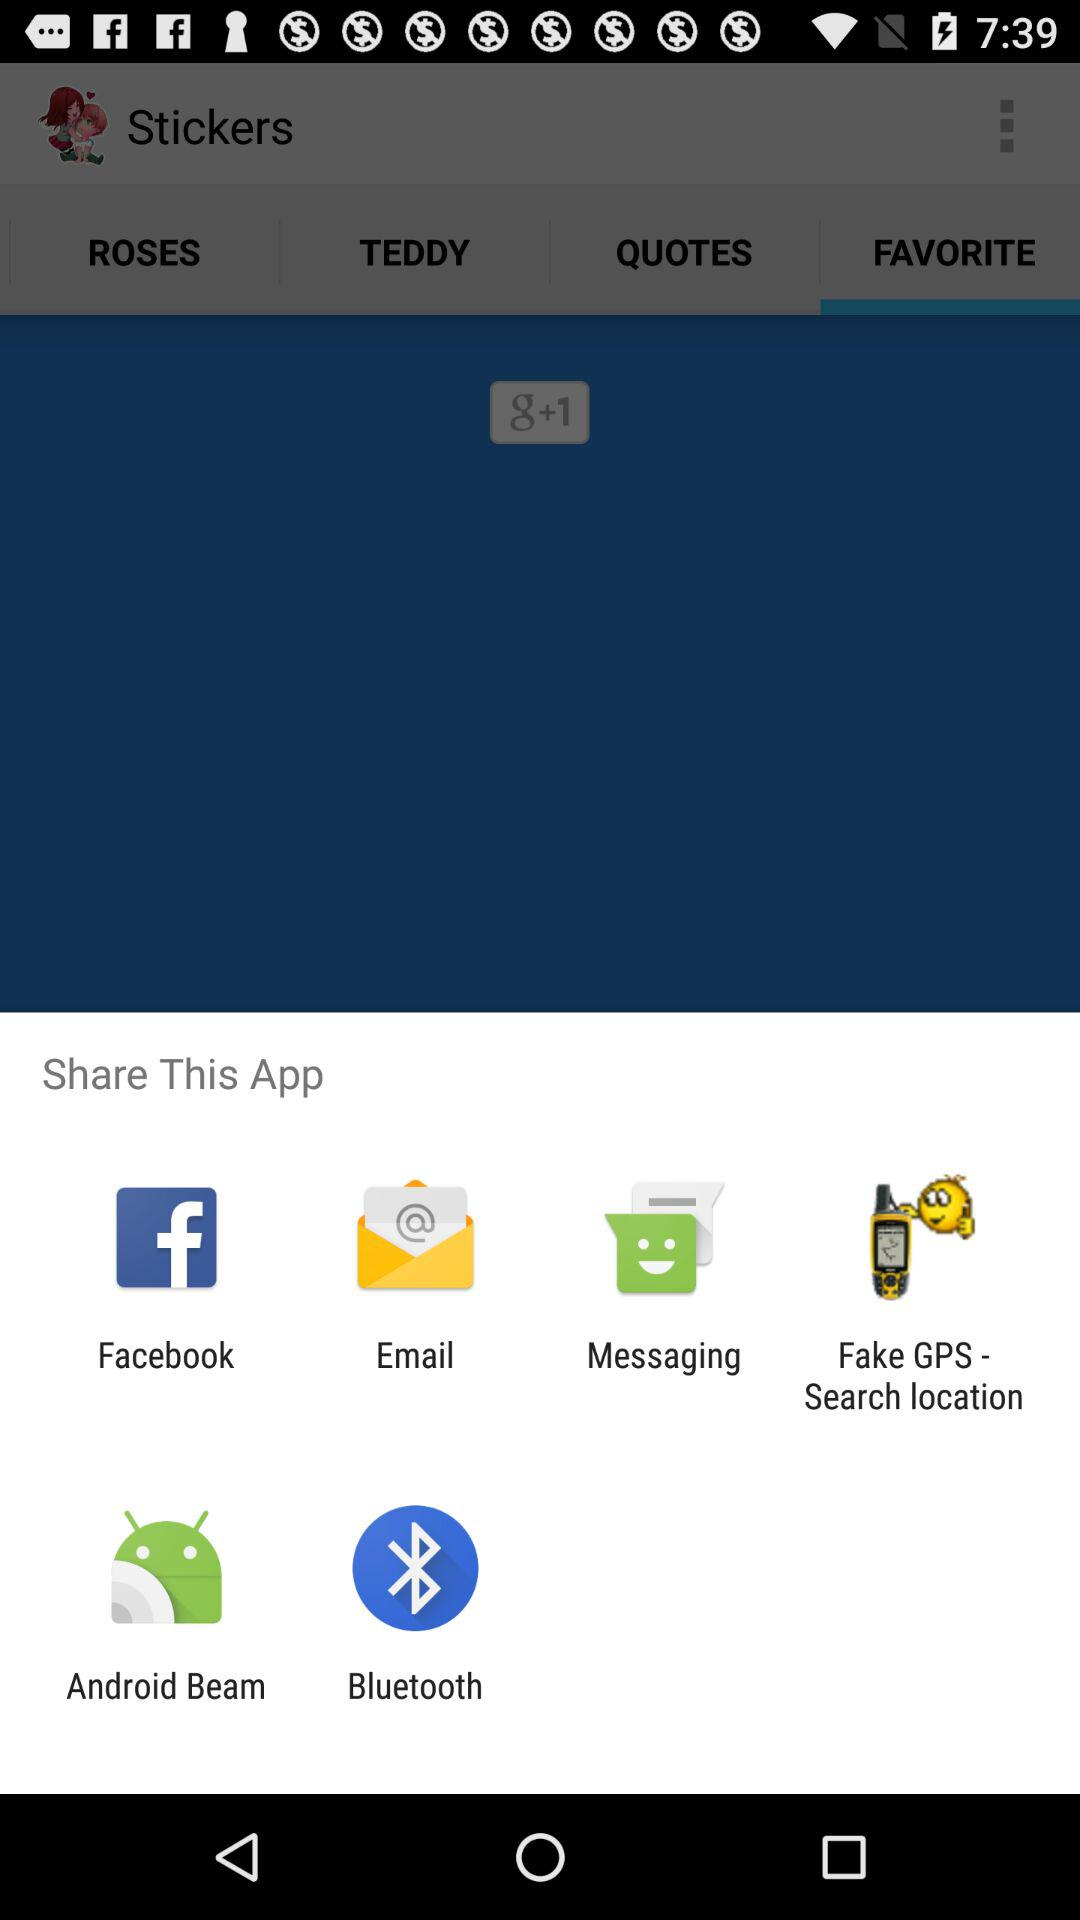By what apps can we share? You can share with "Facebook", "Email", "Messaging", "Fake GPS - Search location", "Android Beam" and "Bluetooth". 